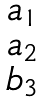<formula> <loc_0><loc_0><loc_500><loc_500>\begin{matrix} a _ { 1 } \\ a _ { 2 } \\ b _ { 3 } \end{matrix}</formula> 